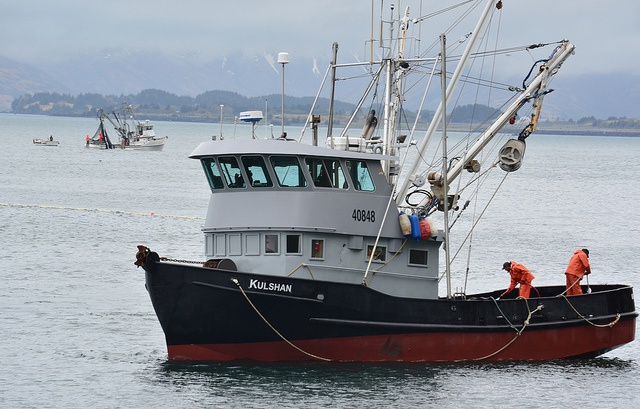Describe the objects in this image and their specific colors. I can see boat in lightblue, black, darkgray, lightgray, and gray tones, boat in lightblue, darkgray, gray, and lightgray tones, people in lightblue, brown, salmon, maroon, and black tones, people in lightblue, brown, maroon, salmon, and red tones, and people in lightblue, black, gray, purple, and teal tones in this image. 